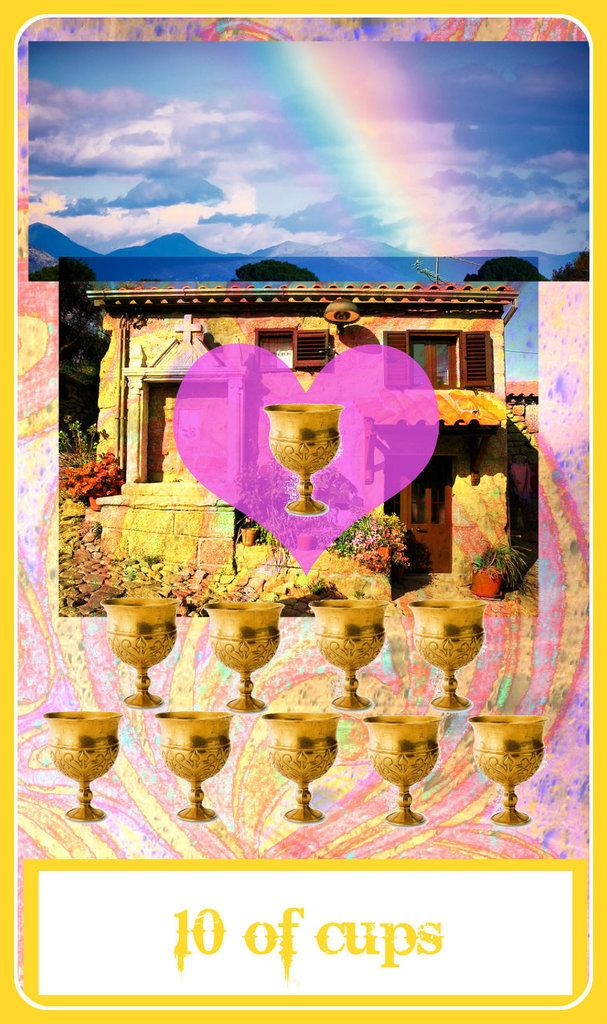Provide a one-sentence caption for the provided image. A card with a house and rainbow and cups reading 10 of cups. 